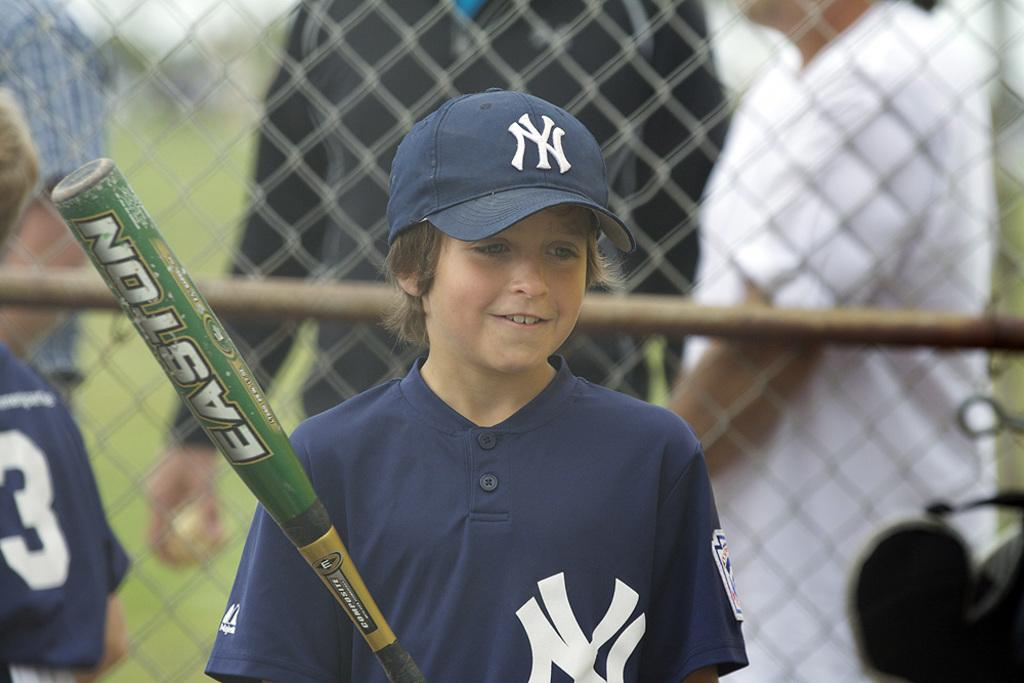<image>
Relay a brief, clear account of the picture shown. A kid is holding a Easton bat while wearing a blue cap. 